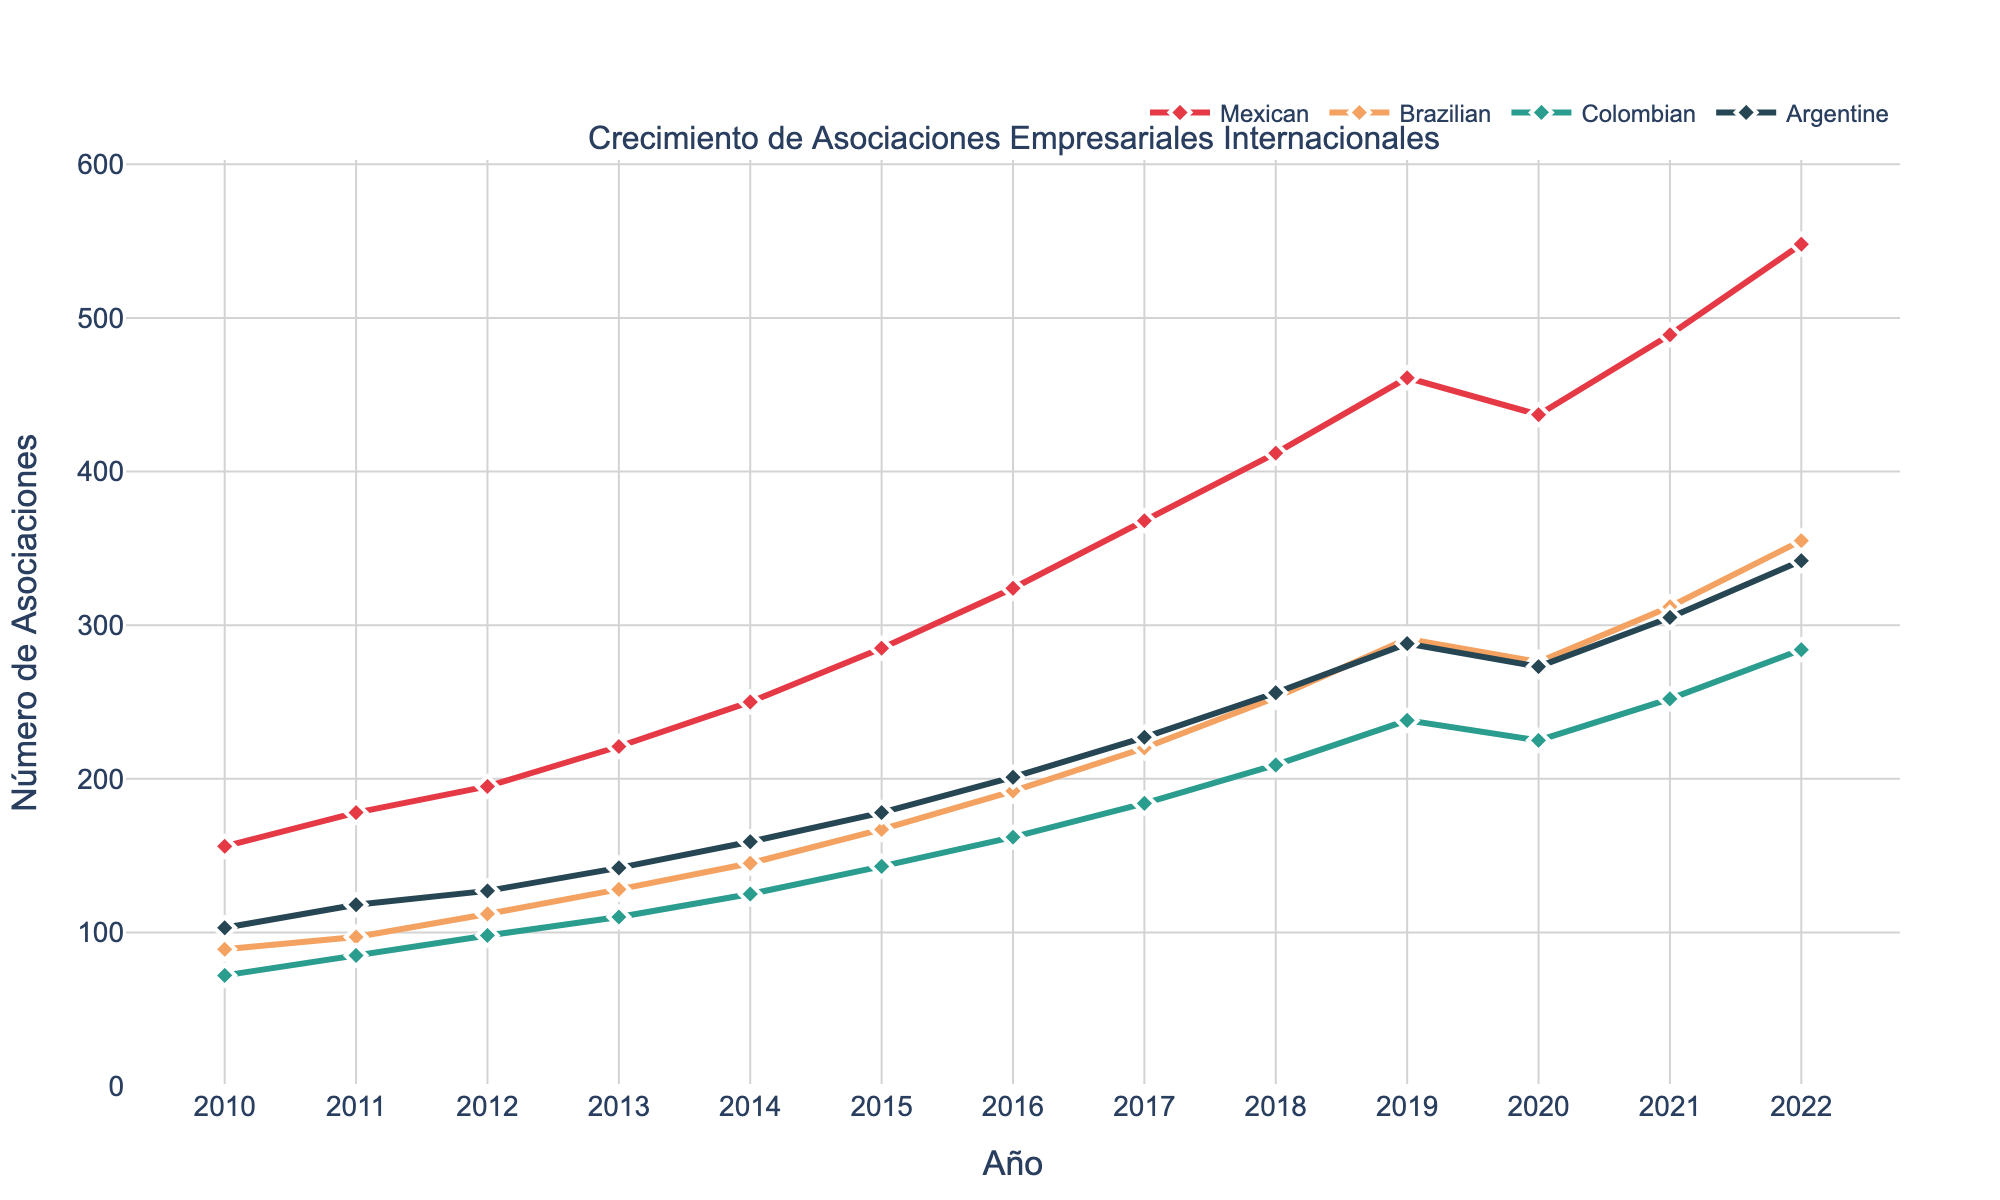What trend do the Spanish-Mexican partnerships show over the period from 2010 to 2022? The Spanish-Mexican partnerships show a general upward trend over the period from 2010 to 2022, starting at 156 in 2010 and ending at 548 in 2022 with a slight dip in 2020.
Answer: Upward trend How did the number of Spanish-Brazilian partnerships change from 2019 to 2020? The number of Spanish-Brazilian partnerships decreased from 291 in 2019 to 276 in 2020.
Answer: Decreased Between Spanish-Colombian and Spanish-Argentine partnerships, which showed a larger increase in the total number from 2010 to 2022? Spanish-Colombian partnerships increased from 72 in 2010 to 284 in 2022, a total increase of 212. Spanish-Argentine partnerships increased from 103 in 2010 to 342 in 2022, a total increase of 239. The larger increase is observed in Spanish-Argentine partnerships.
Answer: Spanish-Argentine partnerships What was the highest recorded number of partnerships for Spanish-Brazilian partnerships within the given period? The highest recorded number of partnerships for Spanish-Brazilian partnerships was 355 in 2022.
Answer: 355 In which year did Spanish-Colombian partnerships first exceed 200? Spanish-Colombian partnerships first exceeded 200 in 2019 with 238 partnerships.
Answer: 2019 Identify the year when all four types of partnerships displayed on the chart reached their peak values together. All four types of partnerships reached their peak values together in the year 2022.
Answer: 2022 What is the percentage increase in Spanish-Mexican partnerships from 2010 to 2022? Spanish-Mexican partnerships increased from 156 in 2010 to 548 in 2022. The percentage increase is calculated as [(548 - 156) / 156] * 100 = 251.28%.
Answer: 251.28% During which year did Spanish-Argentine partnerships experience the largest year-over-year increase? Spanish-Argentine partnerships experienced the largest year-over-year increase from 2021 to 2022, rising from 305 to 342, an increase of 37 partnerships.
Answer: 2021 to 2022 